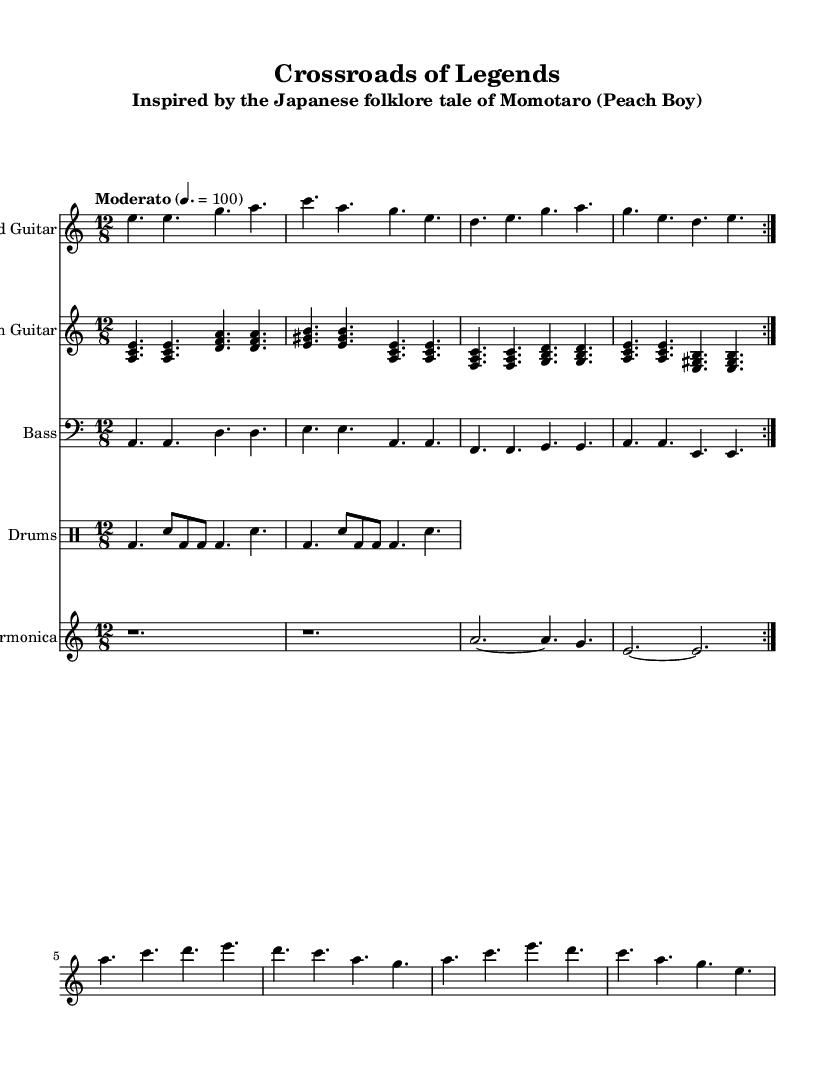What is the key signature of this music? The key signature is indicated right after the clef and shows that there are no sharps or flats, which means it is in A minor.
Answer: A minor What is the time signature of the piece? The time signature is shown at the beginning of the sheet music after the key signature, indicating that the music has four beats in a bar and each beat is a dotted eighth note.
Answer: 12/8 What tempo marking is indicated in the score? The tempo marking is given at the beginning of the piece, stating "Moderato" and indicating the speed of the piece, which is set to a metronome marking of 100 beats per minute.
Answer: Moderato, 100 How many times is the lead guitar part repeated? By examining the lead guitar section, I can observe a repeat sign at the beginning of the section, along with the instructions to play the part two times.
Answer: 2 Which global folk hero is referenced in the subtitle? The subtitle of the music specifies "Inspired by the Japanese folklore tale of Momotaro," thus indicating that the piece references the folk hero Momotaro.
Answer: Momotaro What instruments are featured in this arrangement? A quick scan of the score reveals several staves, each labeled with an instrument name; they include Lead Guitar, Rhythm Guitar, Bass, Drums, and Harmonica.
Answer: Lead Guitar, Rhythm Guitar, Bass, Drums, Harmonica What is the final chord of the rhythm guitar section? By looking at the rhythm guitar part and analyzing the last measure, the notes form the chord A-C-E when played together, which is an A major chord.
Answer: A major 